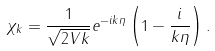Convert formula to latex. <formula><loc_0><loc_0><loc_500><loc_500>\chi _ { k } = \frac { 1 } { \sqrt { 2 V k } } e ^ { - i k \eta } \left ( 1 - \frac { i } { k \eta } \right ) .</formula> 